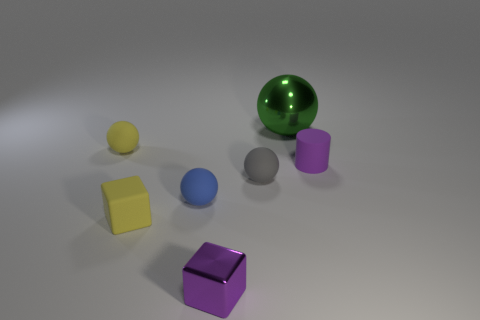Subtract all green spheres. How many spheres are left? 3 Subtract 1 blocks. How many blocks are left? 1 Subtract all gray cubes. Subtract all cyan spheres. How many cubes are left? 2 Subtract all green balls. How many balls are left? 3 Subtract all cylinders. How many objects are left? 6 Subtract all red balls. How many cyan cylinders are left? 0 Subtract all big cyan cylinders. Subtract all gray objects. How many objects are left? 6 Add 7 small blocks. How many small blocks are left? 9 Add 4 metallic objects. How many metallic objects exist? 6 Add 1 big gray metal cubes. How many objects exist? 8 